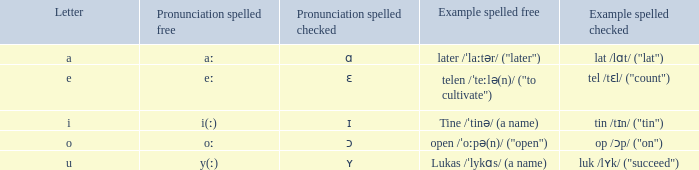What is Pronunciation Spelled Free, when Pronunciation Spelled Checked is "ɛ"? Eː. 